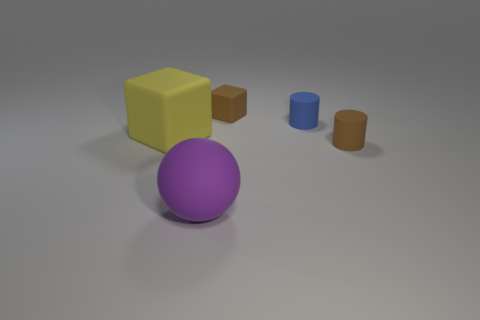Is the number of tiny brown cylinders that are to the left of the large cube less than the number of tiny purple metal blocks?
Provide a succinct answer. No. Do the large yellow thing that is behind the brown matte cylinder and the small brown matte object in front of the yellow rubber thing have the same shape?
Your answer should be compact. No. What number of objects are either small brown objects on the right side of the brown block or large rubber objects?
Offer a very short reply. 3. What material is the thing that is the same color as the tiny cube?
Give a very brief answer. Rubber. There is a rubber cylinder to the left of the matte cylinder on the right side of the blue rubber object; are there any big yellow objects that are behind it?
Your response must be concise. No. Is the number of large purple matte things on the right side of the blue cylinder less than the number of big spheres that are behind the tiny brown rubber cylinder?
Your response must be concise. No. What is the color of the big ball that is the same material as the large cube?
Offer a terse response. Purple. There is a cube that is to the right of the big rubber object in front of the big cube; what color is it?
Your answer should be very brief. Brown. Is there a large rubber sphere of the same color as the big matte cube?
Your answer should be compact. No. The blue thing that is the same size as the brown matte cylinder is what shape?
Keep it short and to the point. Cylinder. 